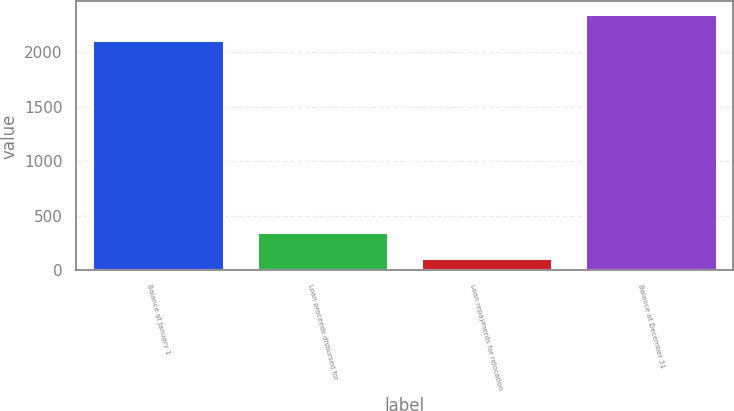Convert chart to OTSL. <chart><loc_0><loc_0><loc_500><loc_500><bar_chart><fcel>Balance at January 1<fcel>Loan proceeds disbursed for<fcel>Loan repayments for relocation<fcel>Balance at December 31<nl><fcel>2113<fcel>350<fcel>115<fcel>2348<nl></chart> 